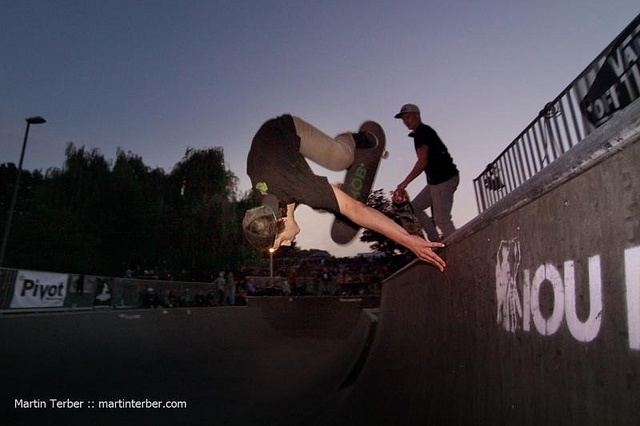Describe the objects in this image and their specific colors. I can see people in darkblue, black, brown, and maroon tones, people in darkblue, black, maroon, gray, and darkgray tones, skateboard in darkblue, black, and gray tones, skateboard in darkblue, black, maroon, and brown tones, and people in black, maroon, and darkblue tones in this image. 